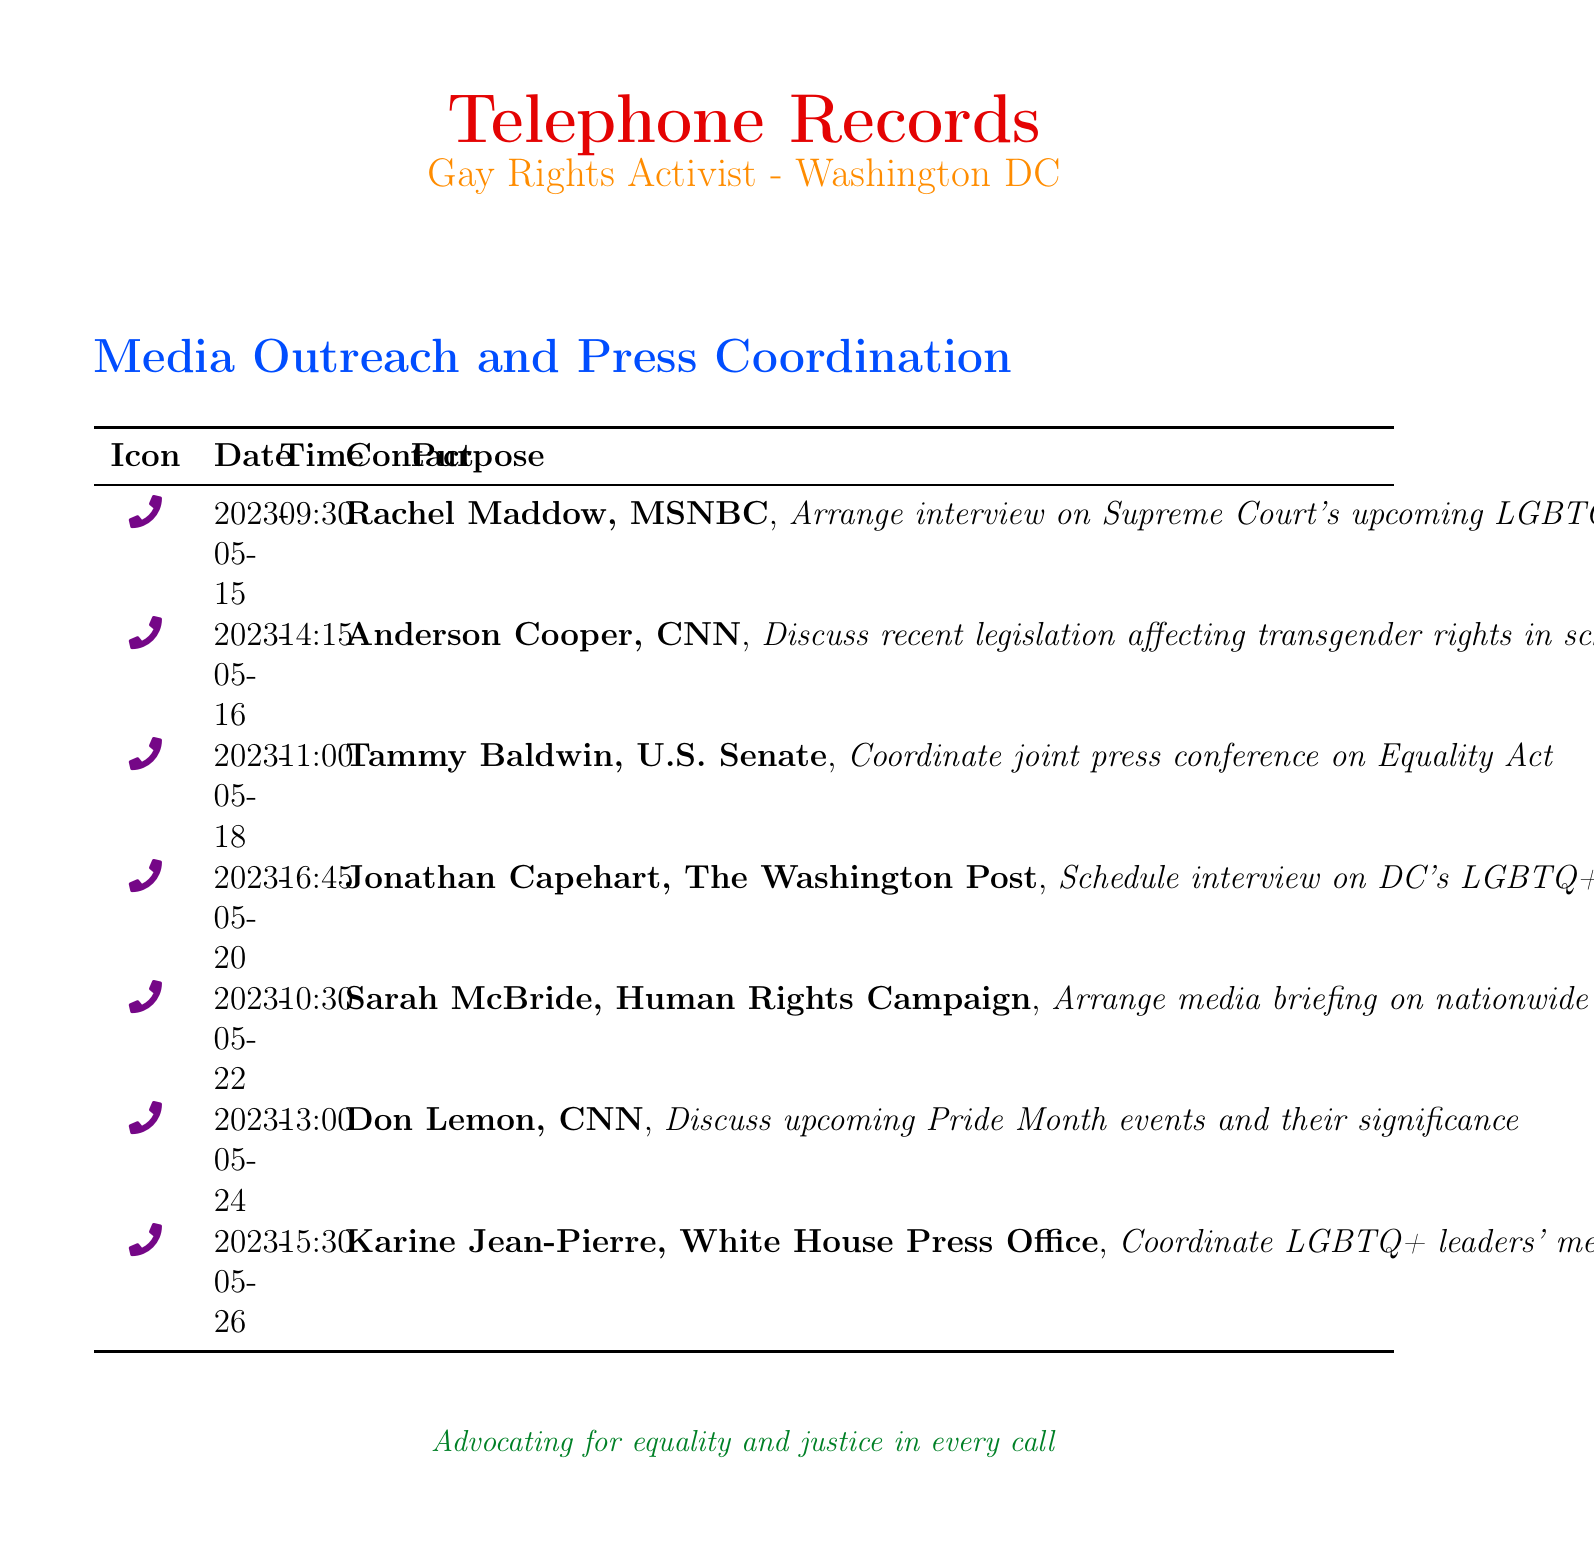What is the date of the call with Rachel Maddow? The date of the call with Rachel Maddow can be found in the records as May 15, 2023.
Answer: May 15, 2023 Who did the activist contact on May 22? The contact made on May 22 was with Sarah McBride from the Human Rights Campaign.
Answer: Sarah McBride What was the purpose of the call with Don Lemon? The purpose of the call with Don Lemon was to discuss upcoming Pride Month events and their significance.
Answer: Discuss upcoming Pride Month events and their significance How many calls were made to media outlets and journalists? The total number of calls listed in the document is counted from each entry, which amounts to seven calls.
Answer: Seven Which media outlet was contacted to arrange a press conference on the Equality Act? The activist contacted Tammy Baldwin from the U.S. Senate to coordinate a joint press conference on the Equality Act.
Answer: U.S. Senate What time was the call with Anderson Cooper? The time of the call with Anderson Cooper is provided in the records as 14:15.
Answer: 14:15 Who was contacted to discuss legislation affecting transgender rights? The activist had a call with Anderson Cooper to discuss legislation affecting transgender rights in schools.
Answer: Anderson Cooper What color is used for the title "Telephone Records"? The color used for the title "Telephone Records" is rainbow red.
Answer: Rainbow red 